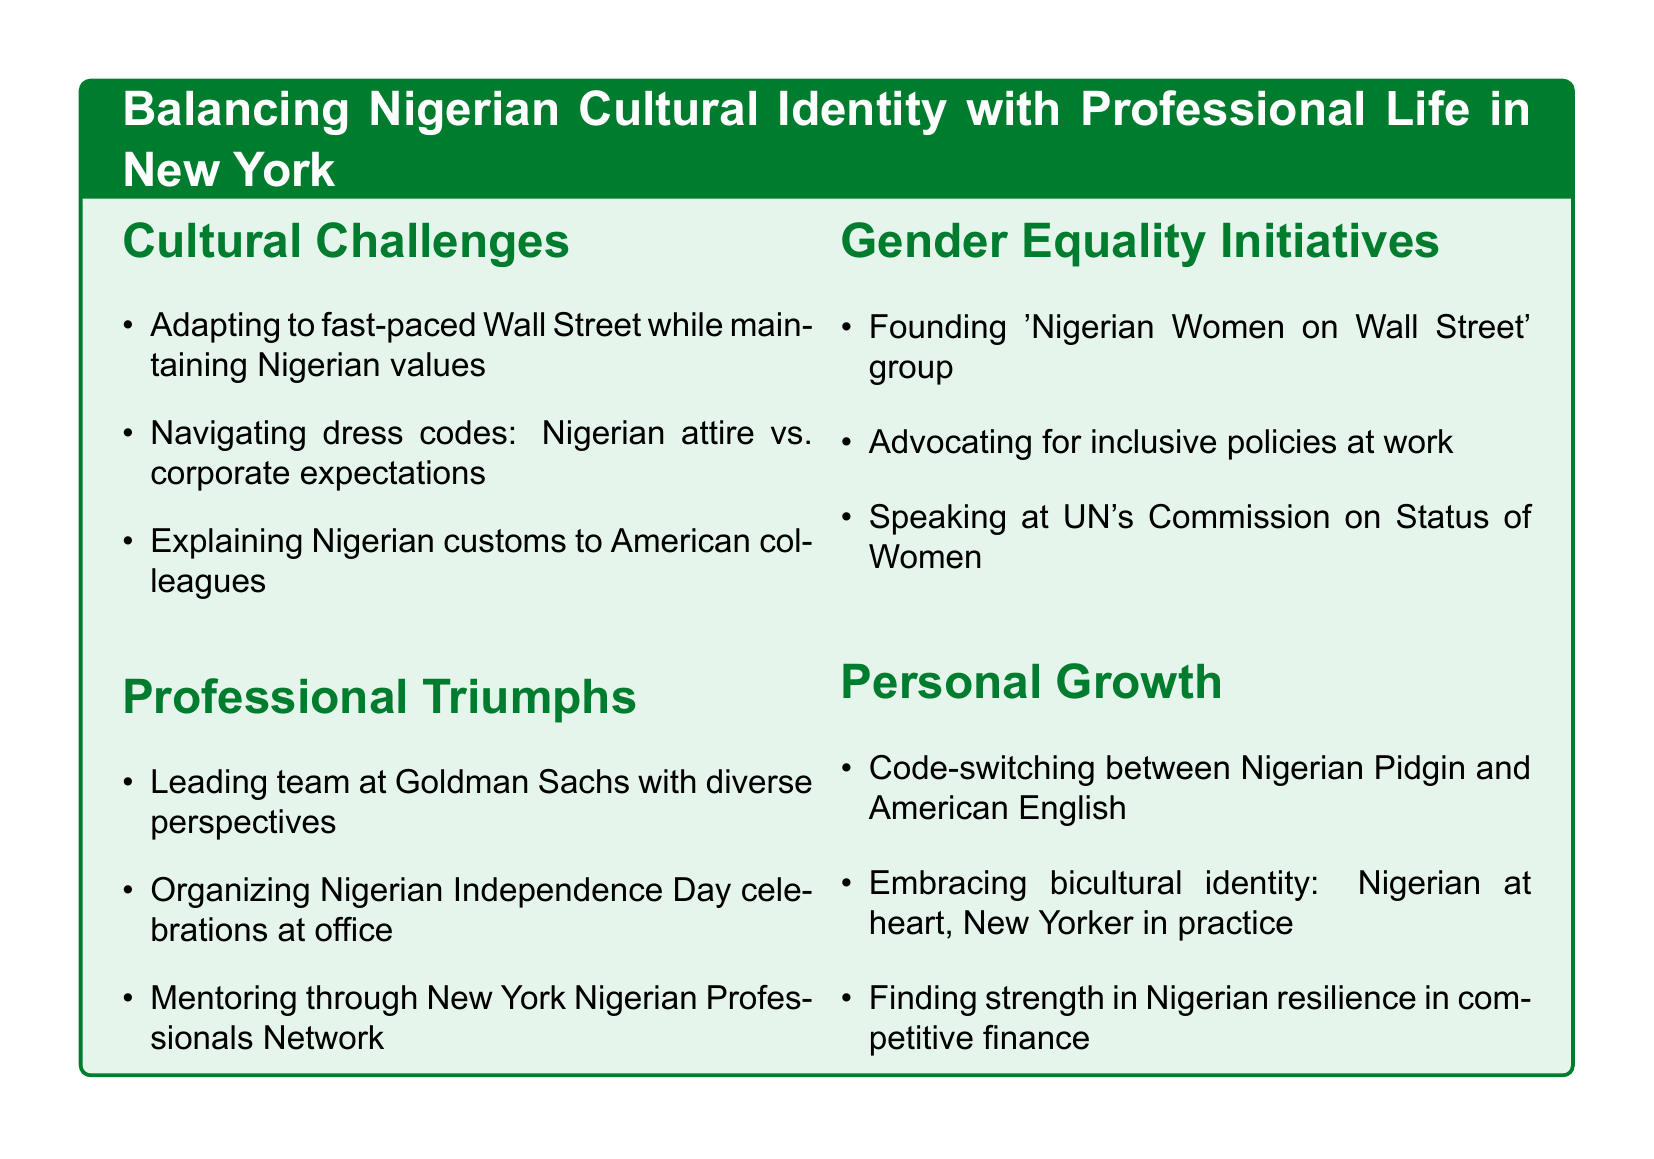what is the title of the document? The title appears at the top of the rendered document and describes the main theme.
Answer: Balancing Nigerian Cultural Identity with Professional Life in New York how many sections are there in the document? The sections of the document can be counted as listed in the structure, providing a clear number.
Answer: 4 what group was founded to support Nigerian women in finance? This information is found in the Gender Equality Initiatives section, detailing the creation of a specific group.
Answer: Nigerian Women on Wall Street what is one cultural challenge mentioned in the document? The document lists various cultural challenges faced, requiring recall of a specific point.
Answer: Adapting to fast-paced Wall Street while maintaining Nigerian values how does the document describe the author's personal growth related to language? The Personal Growth section discusses a specific skill developed in a professional setting.
Answer: Code-switching between Nigerian Pidgin and American English which company is mentioned where the author successfully leads a team? This question seeks to find the specific organization noted in the Professional Triumphs section.
Answer: Goldman Sachs what event does the author organize to promote cultural awareness? The Professional Triumphs section lists an event aimed at enhancing understanding of the Nigerian culture.
Answer: Nigerian Independence Day celebrations name one initiative the author is involved in when speaking at the United Nations. The Gender Equality Initiatives section describes the author's participation in an event, which relates to a broader cause.
Answer: Commission on the Status of Women 